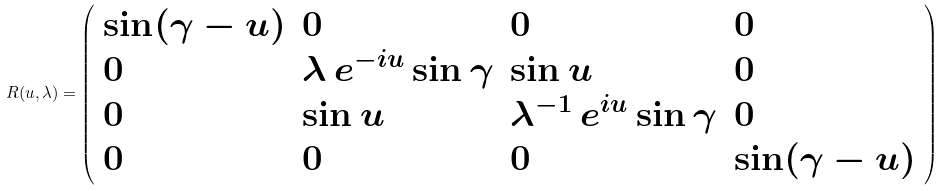Convert formula to latex. <formula><loc_0><loc_0><loc_500><loc_500>R ( u , \lambda ) = \left ( \begin{array} { l l l l } \sin ( \gamma - u ) & 0 & 0 & 0 \\ 0 & \lambda \ e ^ { - i u } \sin \gamma & \sin u & 0 \\ 0 & \sin u & \lambda ^ { - 1 } \ e ^ { i u } \sin \gamma & 0 \\ 0 & 0 & 0 & \sin ( \gamma - u ) \end{array} \right )</formula> 